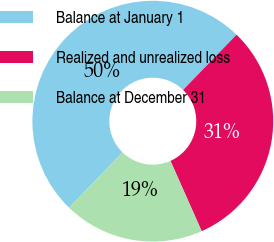Convert chart to OTSL. <chart><loc_0><loc_0><loc_500><loc_500><pie_chart><fcel>Balance at January 1<fcel>Realized and unrealized loss<fcel>Balance at December 31<nl><fcel>50.0%<fcel>31.1%<fcel>18.9%<nl></chart> 